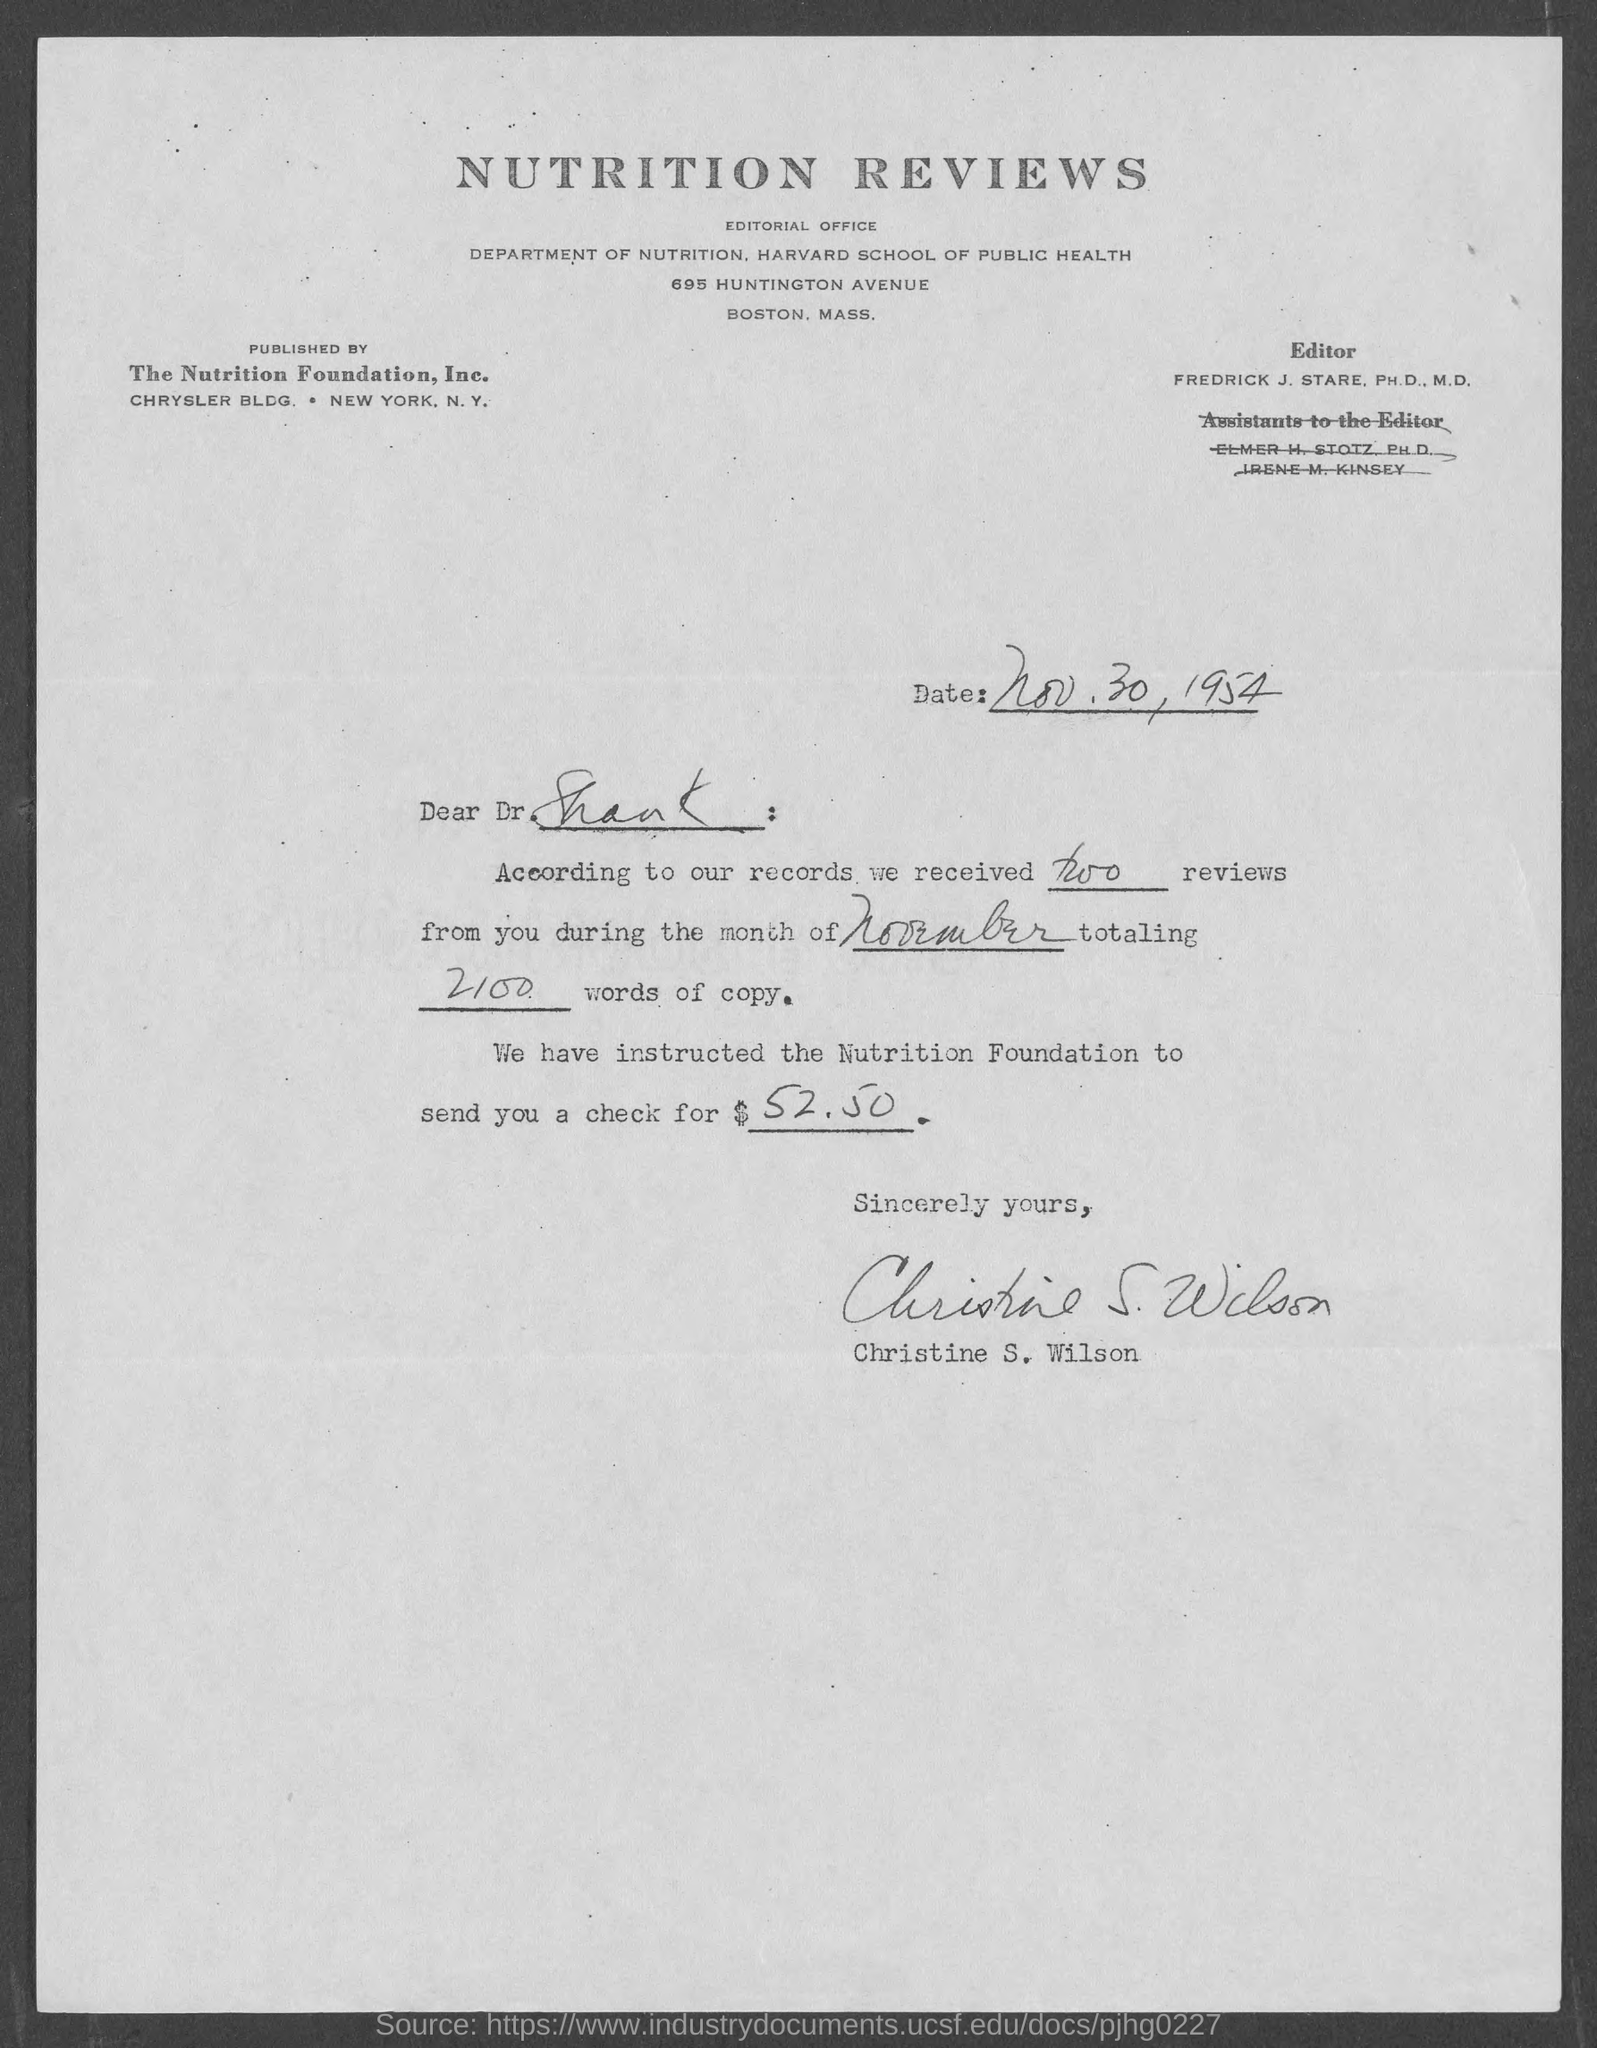List a handful of essential elements in this visual. The addressee of this letter is Dr. Shank. The letter has been signed by Christine S. Wilson. The date mentioned in this letter is November 30, 1954. The check amount mentioned in the letter is $52.50. 